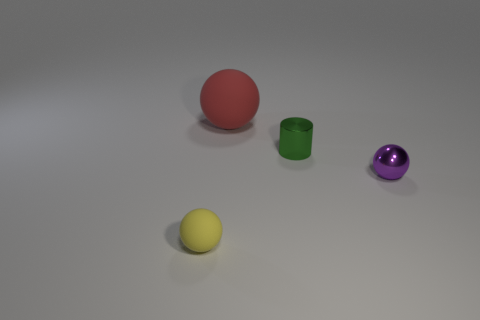Add 3 large spheres. How many objects exist? 7 Subtract all balls. How many objects are left? 1 Subtract all tiny cyan shiny cylinders. Subtract all green metal things. How many objects are left? 3 Add 3 red matte things. How many red matte things are left? 4 Add 3 large rubber things. How many large rubber things exist? 4 Subtract 0 green spheres. How many objects are left? 4 